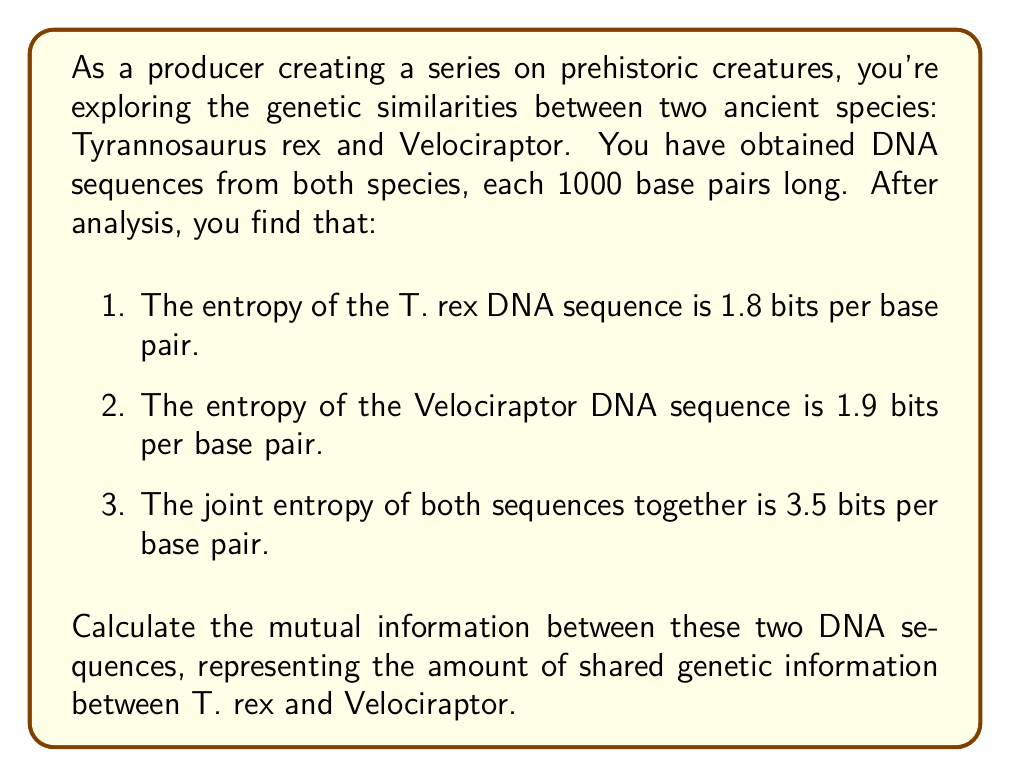Help me with this question. To solve this problem, we'll use the concept of mutual information from information theory. The mutual information $I(X;Y)$ between two random variables X and Y is defined as:

$$I(X;Y) = H(X) + H(Y) - H(X,Y)$$

Where:
- $H(X)$ is the entropy of X
- $H(Y)$ is the entropy of Y
- $H(X,Y)$ is the joint entropy of X and Y

In our case:
- X represents the T. rex DNA sequence
- Y represents the Velociraptor DNA sequence

Given:
- $H(X) = 1.8$ bits per base pair
- $H(Y) = 1.9$ bits per base pair
- $H(X,Y) = 3.5$ bits per base pair

Let's substitute these values into the mutual information formula:

$$I(X;Y) = H(X) + H(Y) - H(X,Y)$$
$$I(X;Y) = 1.8 + 1.9 - 3.5$$
$$I(X;Y) = 0.2$$ bits per base pair

To get the total mutual information for the entire 1000 base pair sequence, we multiply by 1000:

$$I_{total}(X;Y) = 0.2 \times 1000 = 200$$ bits

This result indicates that there are 200 bits of shared information between the T. rex and Velociraptor DNA sequences, suggesting some genetic similarity between these two prehistoric species.
Answer: The mutual information between the T. rex and Velociraptor DNA sequences is 0.2 bits per base pair, or 200 bits for the entire 1000 base pair sequence. 